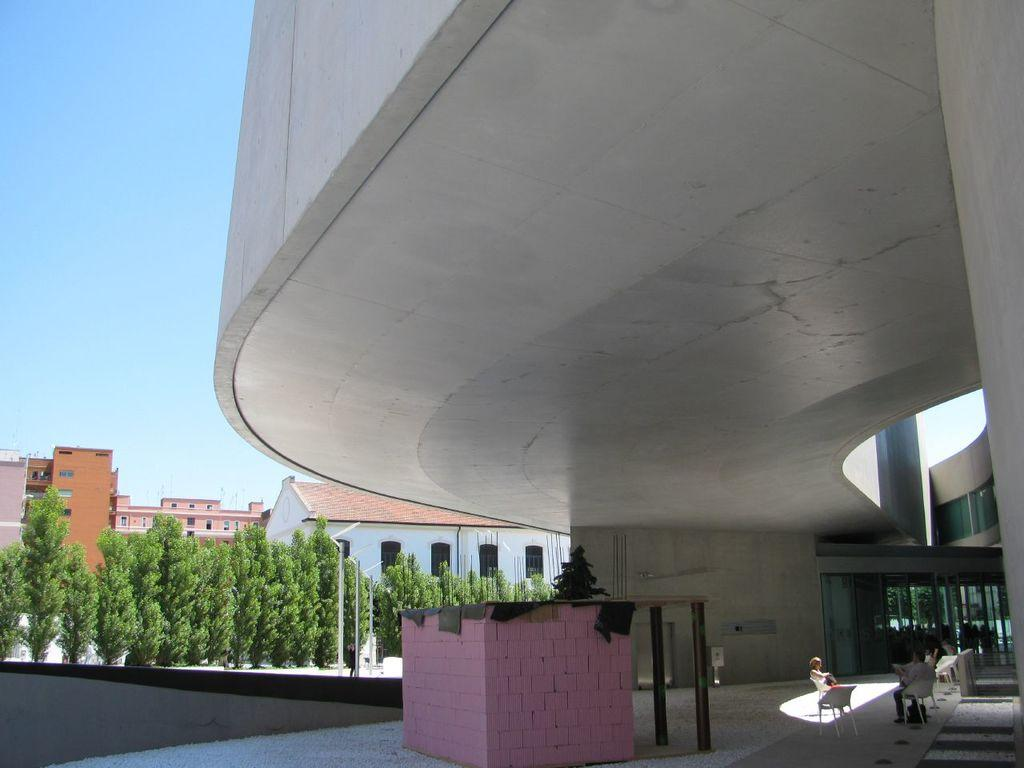What type of structures can be seen in the image? There are buildings in the image. What are the persons in the image doing? The persons in the image are sitting on chairs. Where is the scene taking place? The scene is taking place in a room, as indicated by the presence of chairs and walls. What else can be seen in the room? There are clothes and poles visible in the room. What is visible outside the room? The sky is visible in the image. Can you tell me how many cubs are playing with a quill in the image? There are no cubs or quills present in the image. What type of pickle is being used as a decoration in the room? There is no pickle present in the image, and therefore it cannot be used as a decoration. 